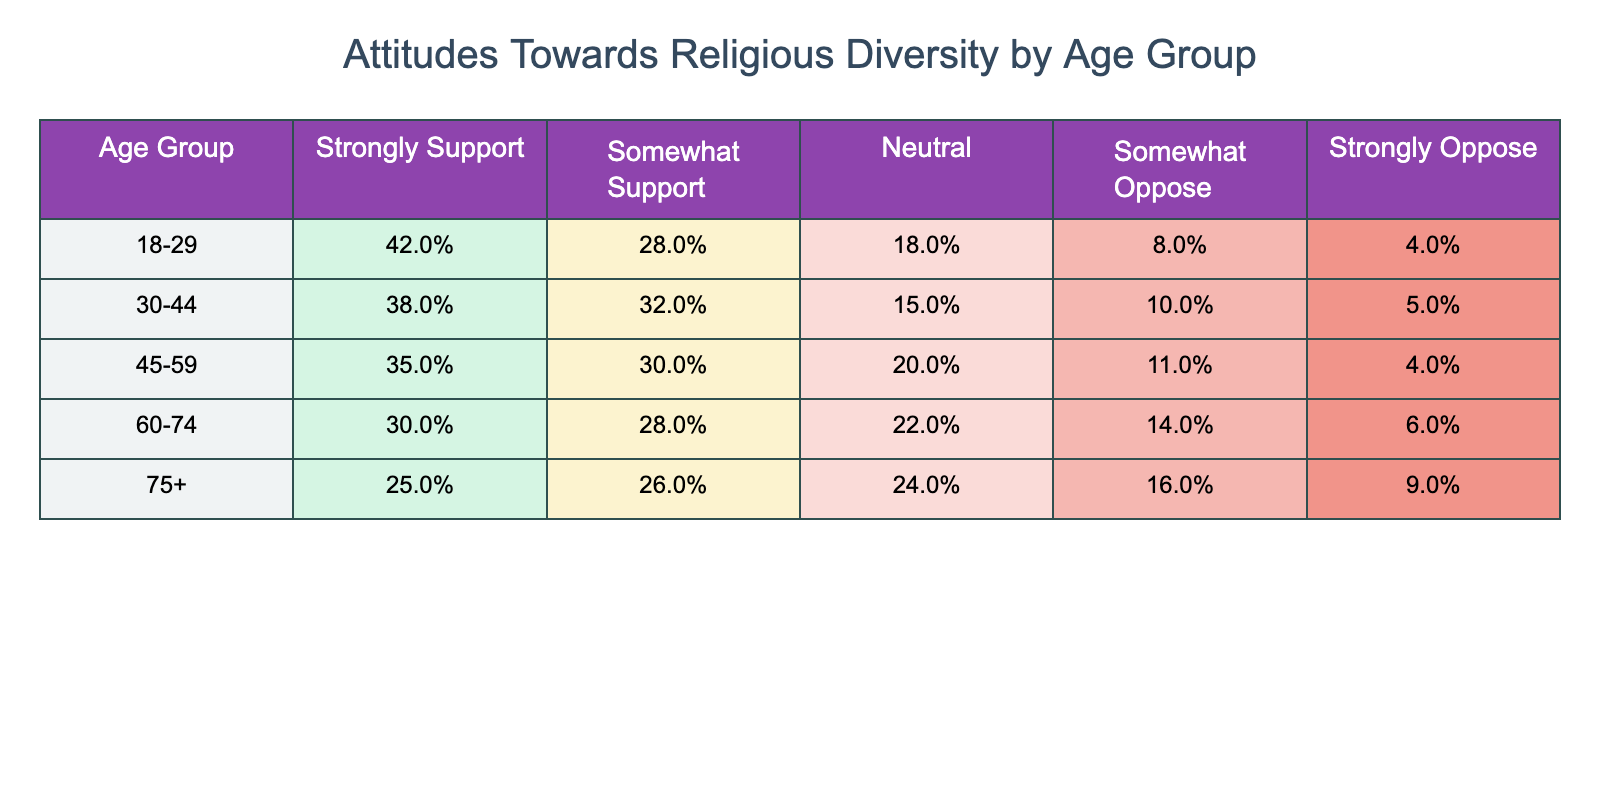What percentage of the 18-29 age group strongly supports religious diversity? The table shows that 42% of the 18-29 age group strongly support religious diversity.
Answer: 42% Which age group has the highest percentage of individuals who are neutral about religious diversity? Looking at the table, the highest percentage of neutral responses is 24% from the 75+ age group.
Answer: 75+ What is the difference in the percentage of those who strongly support religious diversity between the 30-44 and 60-74 age groups? The 30-44 age group has 38% and the 60-74 age group has 30%, so the difference is 38% - 30% = 8%.
Answer: 8% What is the total percentage of individuals in the 45-59 age group who either support or strongly support religious diversity? The 45-59 age group has 35% strongly support and 30% somewhat support, thus the total is 35% + 30% = 65%.
Answer: 65% Which age group is less supportive of religious diversity: 60-74 or 75+? The 60-74 group has only 30% strongly support, while the 75+ group has 25%, indicating that the 75+ age group is less supportive.
Answer: 75+ What is the average percentage of strong support across all age groups represented? The percentages for strong support are 42%, 38%, 35%, 30%, and 25%. Adding these gives 170%, and dividing by 5 gives an average of 34%.
Answer: 34% Does the percentage of those who strongly oppose religious diversity increase with age? Yes, the percentages for strong opposition are 4%, 5%, 4%, 6%, and 9%, indicating an upward trend as age increases.
Answer: Yes Which age group has the lowest percentage of support (strongly support + somewhat support)? For the 75+ age group, the percentages are 25% (strongly support) and 26% (somewhat support), totaling 51%, which is lower than all other groups.
Answer: 75+ What portion of the 60-74 age group is opposed to religious diversity (somewhat oppose + strongly oppose)? The 60-74 age group has 14% somewhat oppose and 6% strongly oppose, totaling 14% + 6% = 20%.
Answer: 20% Is the percentage of somewhat support higher in the 30-44 age group compared to the 18-29 age group? Yes, the 30-44 age group has 32% somewhat support, while the 18-29 age group has 28%. Thus, 32% > 28%.
Answer: Yes 